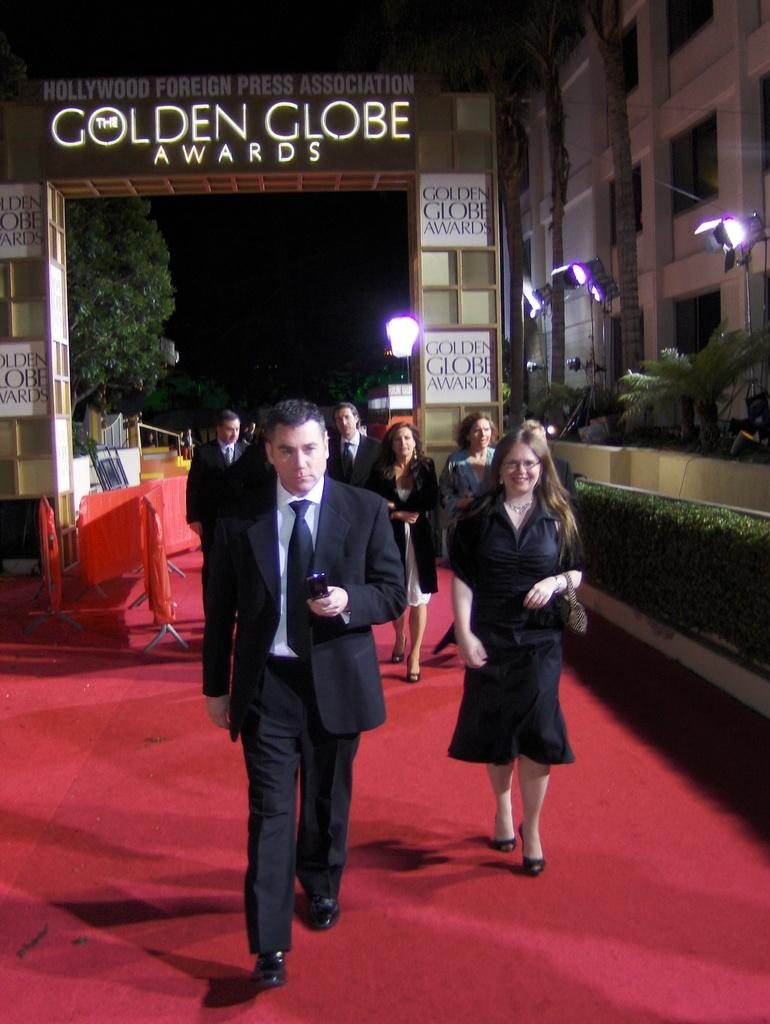Who or what can be seen in the image? There are people in the image. What type of structures are visible in the image? There are buildings in the image. What are the boards used for in the image? Something is written on the boards, which suggests they might be used for displaying information or messages. What can be seen in the sky in the image? There are lights in the image, which might indicate that the scene is taking place at night or in a dimly lit area. What type of vegetation is present in the image? There are trees and plants in the image. What is the red carpet used for in the image? The red carpet might be used as a decorative element or to guide people in a specific direction. What other objects can be seen in the image? There are objects in the image, but their specific purpose or appearance cannot be determined from the provided facts. What type of feast is being prepared on the wing in the image? There is no mention of a feast or a wing in the image. What type of wood is used to construct the buildings in the image? The type of wood used to construct the buildings cannot be determined from the provided facts. 